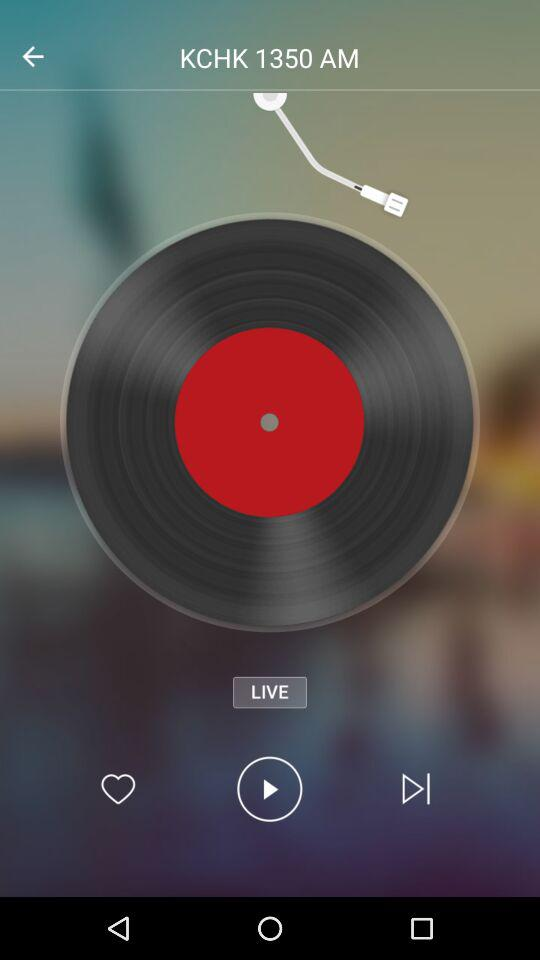What is the song's name? The song's name is "KCHK 1350 AM". 